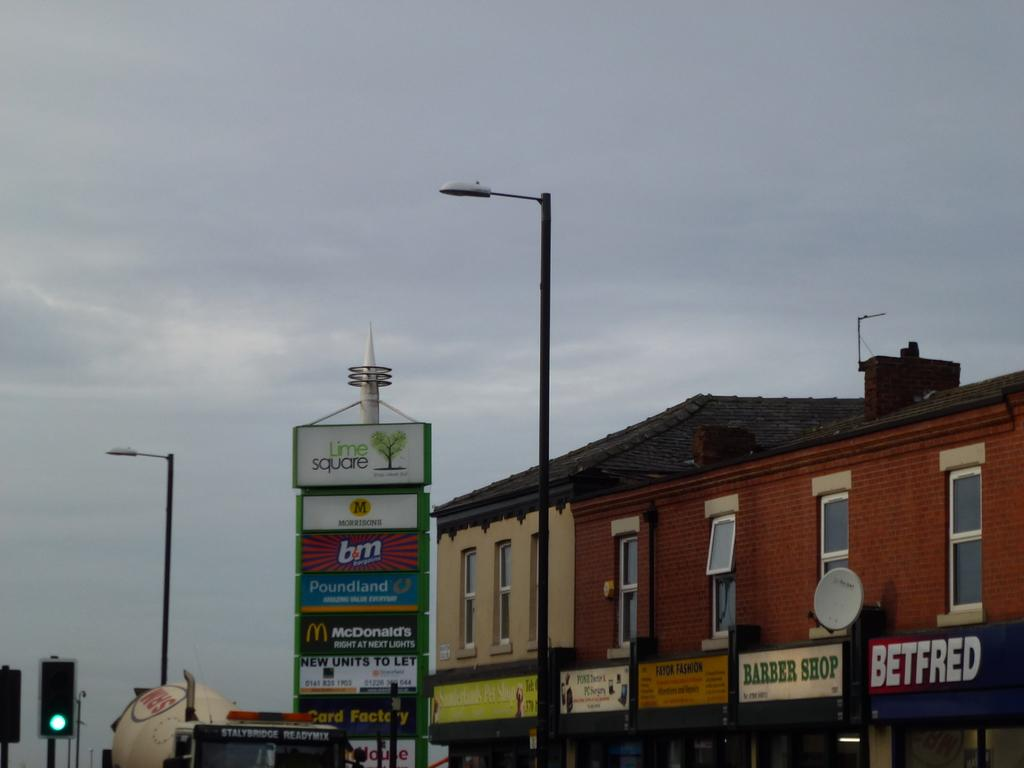<image>
Summarize the visual content of the image. A shop called Morrisons is in the Lime Square plaza. 